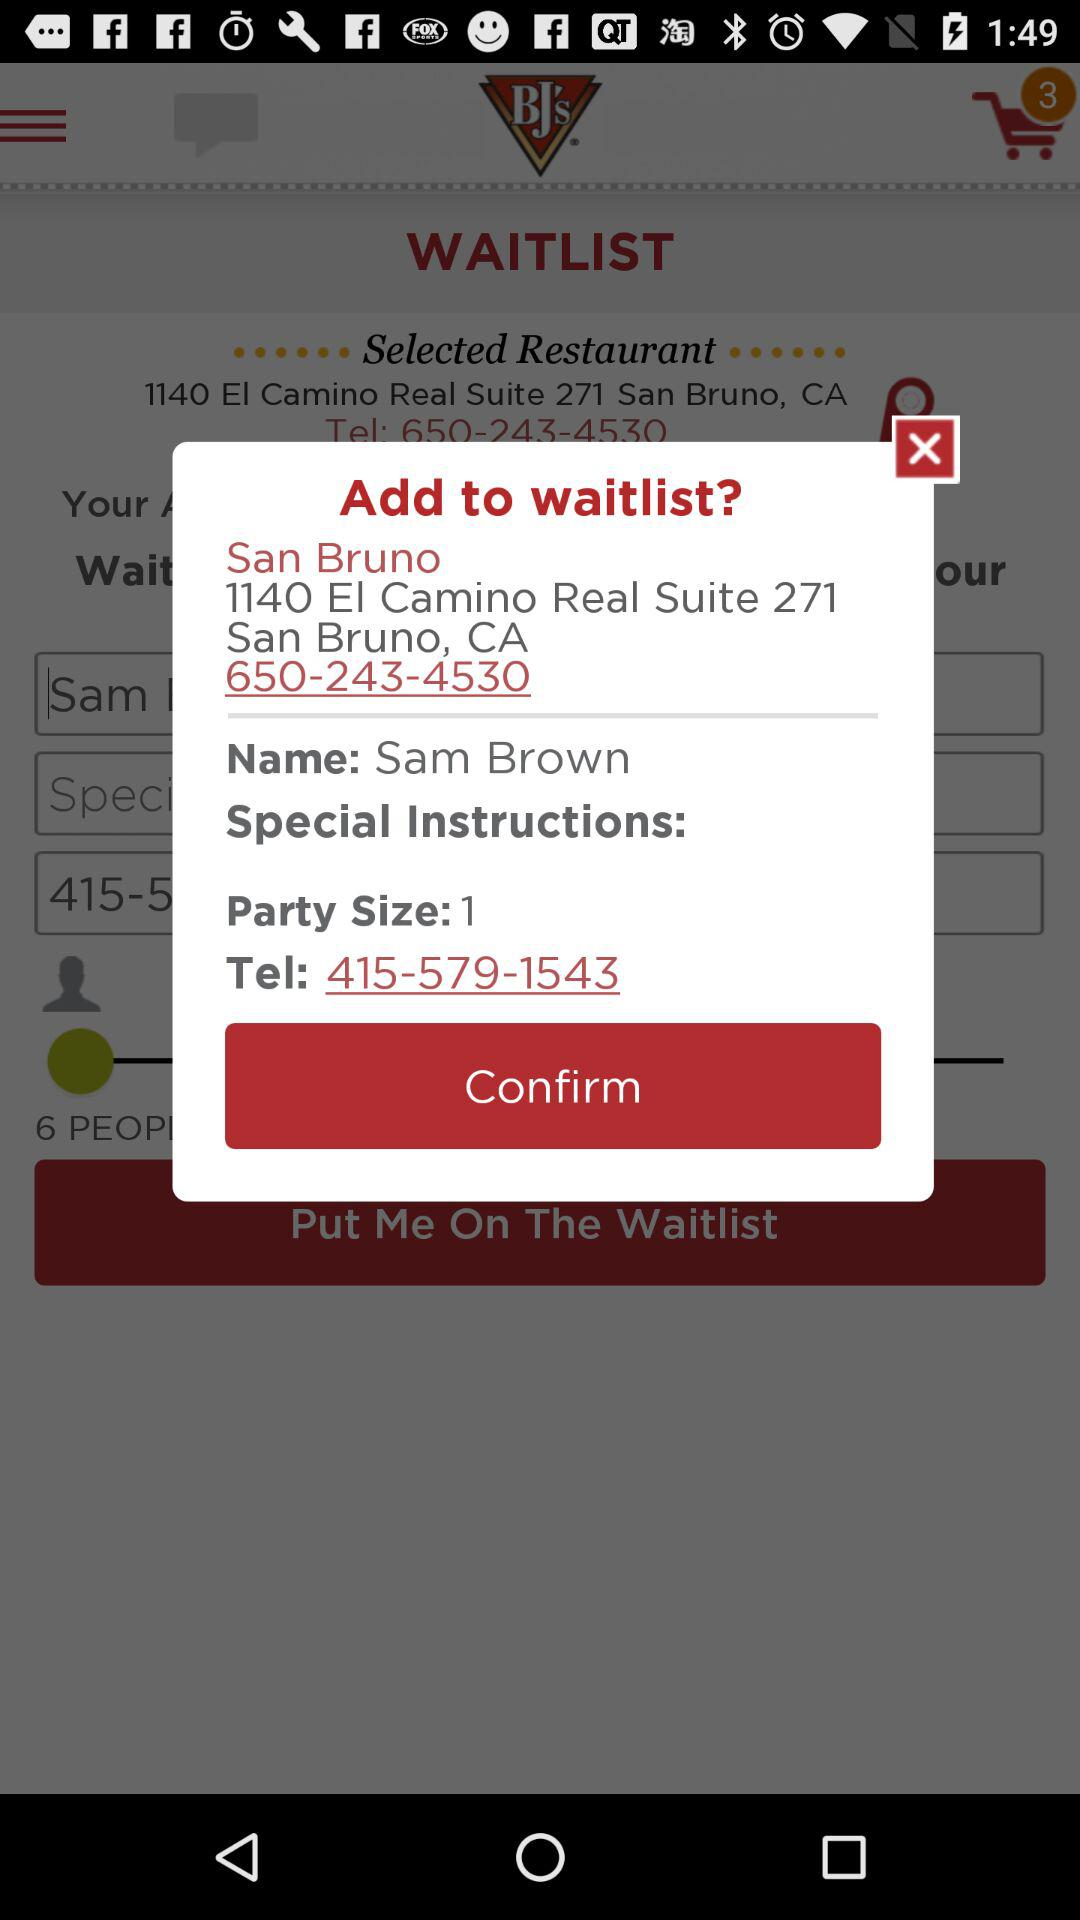What is the total number of products in the shopping cart? The total number of products in the shopping cart is 3. 